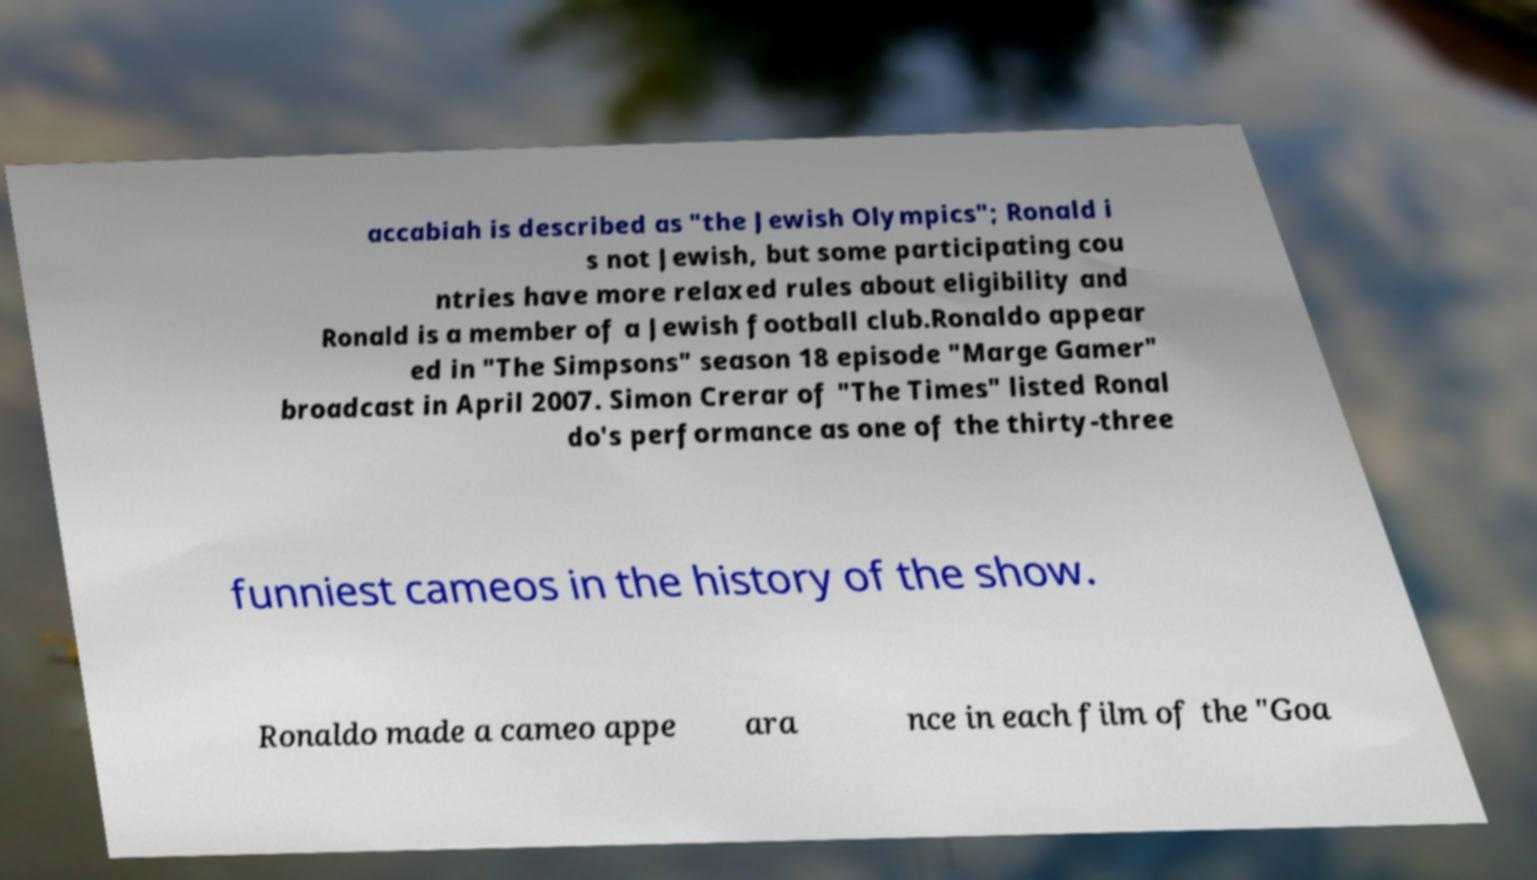Please read and relay the text visible in this image. What does it say? accabiah is described as "the Jewish Olympics"; Ronald i s not Jewish, but some participating cou ntries have more relaxed rules about eligibility and Ronald is a member of a Jewish football club.Ronaldo appear ed in "The Simpsons" season 18 episode "Marge Gamer" broadcast in April 2007. Simon Crerar of "The Times" listed Ronal do's performance as one of the thirty-three funniest cameos in the history of the show. Ronaldo made a cameo appe ara nce in each film of the "Goa 